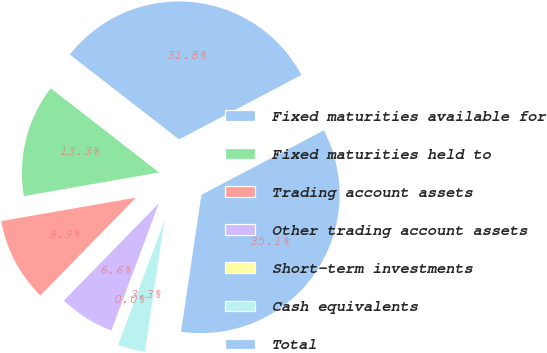Convert chart. <chart><loc_0><loc_0><loc_500><loc_500><pie_chart><fcel>Fixed maturities available for<fcel>Fixed maturities held to<fcel>Trading account assets<fcel>Other trading account assets<fcel>Short-term investments<fcel>Cash equivalents<fcel>Total<nl><fcel>31.77%<fcel>13.26%<fcel>9.94%<fcel>6.63%<fcel>0.0%<fcel>3.32%<fcel>35.08%<nl></chart> 